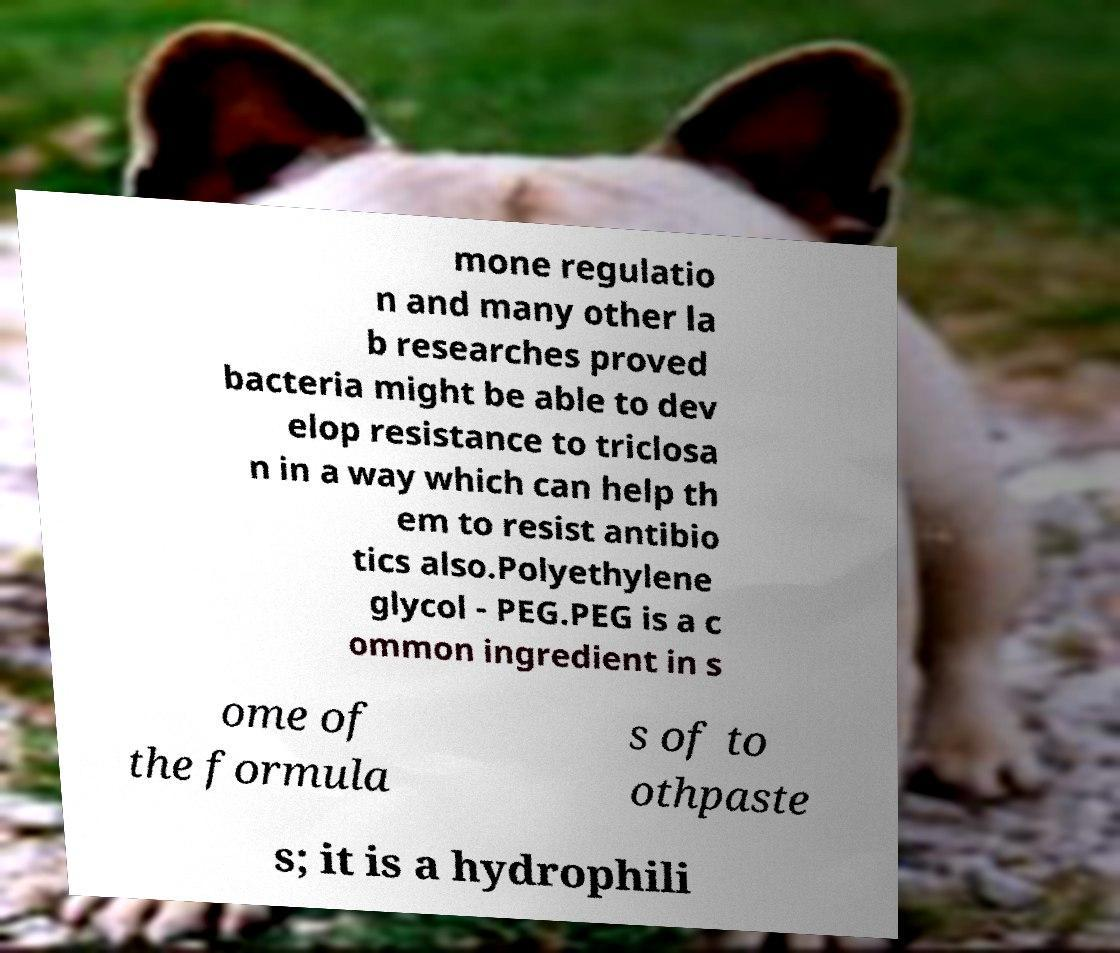Could you extract and type out the text from this image? mone regulatio n and many other la b researches proved bacteria might be able to dev elop resistance to triclosa n in a way which can help th em to resist antibio tics also.Polyethylene glycol - PEG.PEG is a c ommon ingredient in s ome of the formula s of to othpaste s; it is a hydrophili 